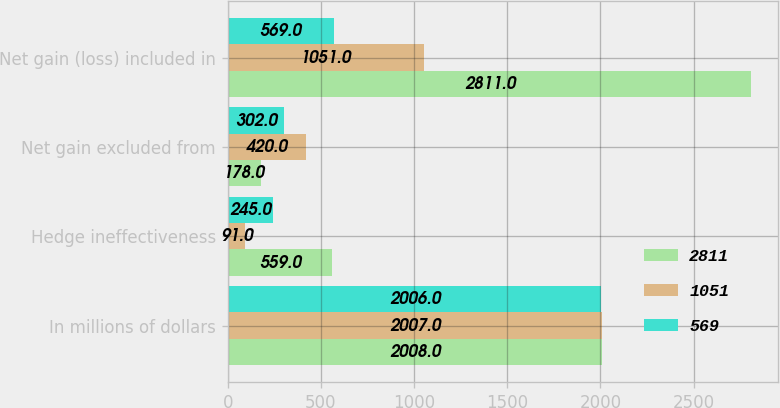<chart> <loc_0><loc_0><loc_500><loc_500><stacked_bar_chart><ecel><fcel>In millions of dollars<fcel>Hedge ineffectiveness<fcel>Net gain excluded from<fcel>Net gain (loss) included in<nl><fcel>2811<fcel>2008<fcel>559<fcel>178<fcel>2811<nl><fcel>1051<fcel>2007<fcel>91<fcel>420<fcel>1051<nl><fcel>569<fcel>2006<fcel>245<fcel>302<fcel>569<nl></chart> 